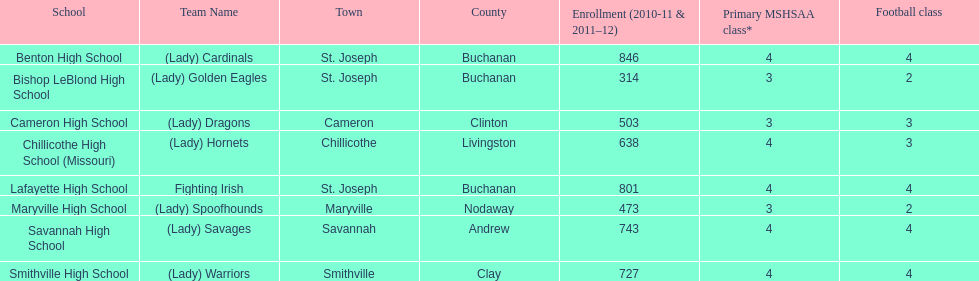How many educational institutions are present in this conference? 8. 